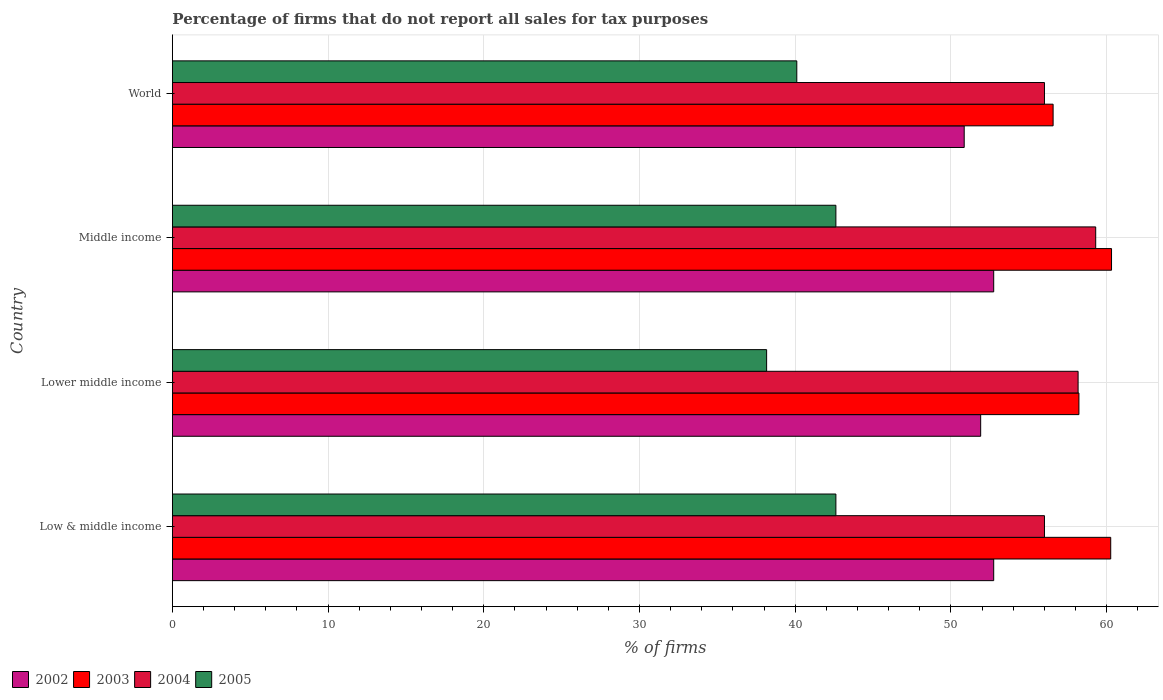How many different coloured bars are there?
Ensure brevity in your answer.  4. How many groups of bars are there?
Offer a terse response. 4. Are the number of bars per tick equal to the number of legend labels?
Your response must be concise. Yes. How many bars are there on the 4th tick from the bottom?
Provide a succinct answer. 4. In how many cases, is the number of bars for a given country not equal to the number of legend labels?
Give a very brief answer. 0. What is the percentage of firms that do not report all sales for tax purposes in 2002 in Lower middle income?
Give a very brief answer. 51.91. Across all countries, what is the maximum percentage of firms that do not report all sales for tax purposes in 2002?
Ensure brevity in your answer.  52.75. Across all countries, what is the minimum percentage of firms that do not report all sales for tax purposes in 2002?
Offer a very short reply. 50.85. In which country was the percentage of firms that do not report all sales for tax purposes in 2005 minimum?
Your response must be concise. Lower middle income. What is the total percentage of firms that do not report all sales for tax purposes in 2005 in the graph?
Offer a very short reply. 163.48. What is the difference between the percentage of firms that do not report all sales for tax purposes in 2005 in Lower middle income and that in Middle income?
Make the answer very short. -4.45. What is the difference between the percentage of firms that do not report all sales for tax purposes in 2003 in Lower middle income and the percentage of firms that do not report all sales for tax purposes in 2004 in Middle income?
Keep it short and to the point. -1.08. What is the average percentage of firms that do not report all sales for tax purposes in 2005 per country?
Make the answer very short. 40.87. What is the difference between the percentage of firms that do not report all sales for tax purposes in 2005 and percentage of firms that do not report all sales for tax purposes in 2003 in Low & middle income?
Your answer should be compact. -17.65. What is the ratio of the percentage of firms that do not report all sales for tax purposes in 2002 in Low & middle income to that in Lower middle income?
Offer a very short reply. 1.02. Is the percentage of firms that do not report all sales for tax purposes in 2002 in Middle income less than that in World?
Keep it short and to the point. No. What is the difference between the highest and the second highest percentage of firms that do not report all sales for tax purposes in 2004?
Offer a very short reply. 1.13. What is the difference between the highest and the lowest percentage of firms that do not report all sales for tax purposes in 2002?
Provide a short and direct response. 1.89. In how many countries, is the percentage of firms that do not report all sales for tax purposes in 2005 greater than the average percentage of firms that do not report all sales for tax purposes in 2005 taken over all countries?
Your response must be concise. 2. Is the sum of the percentage of firms that do not report all sales for tax purposes in 2005 in Low & middle income and Lower middle income greater than the maximum percentage of firms that do not report all sales for tax purposes in 2004 across all countries?
Offer a terse response. Yes. What does the 1st bar from the top in Middle income represents?
Provide a succinct answer. 2005. What does the 4th bar from the bottom in Middle income represents?
Offer a terse response. 2005. Is it the case that in every country, the sum of the percentage of firms that do not report all sales for tax purposes in 2002 and percentage of firms that do not report all sales for tax purposes in 2004 is greater than the percentage of firms that do not report all sales for tax purposes in 2003?
Keep it short and to the point. Yes. How many bars are there?
Your answer should be very brief. 16. Are all the bars in the graph horizontal?
Give a very brief answer. Yes. What is the difference between two consecutive major ticks on the X-axis?
Your answer should be compact. 10. Are the values on the major ticks of X-axis written in scientific E-notation?
Provide a short and direct response. No. How many legend labels are there?
Your answer should be compact. 4. What is the title of the graph?
Offer a terse response. Percentage of firms that do not report all sales for tax purposes. What is the label or title of the X-axis?
Offer a very short reply. % of firms. What is the label or title of the Y-axis?
Provide a short and direct response. Country. What is the % of firms of 2002 in Low & middle income?
Your answer should be very brief. 52.75. What is the % of firms of 2003 in Low & middle income?
Provide a short and direct response. 60.26. What is the % of firms in 2004 in Low & middle income?
Provide a succinct answer. 56.01. What is the % of firms of 2005 in Low & middle income?
Offer a very short reply. 42.61. What is the % of firms in 2002 in Lower middle income?
Keep it short and to the point. 51.91. What is the % of firms in 2003 in Lower middle income?
Keep it short and to the point. 58.22. What is the % of firms of 2004 in Lower middle income?
Ensure brevity in your answer.  58.16. What is the % of firms in 2005 in Lower middle income?
Ensure brevity in your answer.  38.16. What is the % of firms of 2002 in Middle income?
Give a very brief answer. 52.75. What is the % of firms in 2003 in Middle income?
Give a very brief answer. 60.31. What is the % of firms in 2004 in Middle income?
Offer a terse response. 59.3. What is the % of firms in 2005 in Middle income?
Keep it short and to the point. 42.61. What is the % of firms of 2002 in World?
Keep it short and to the point. 50.85. What is the % of firms of 2003 in World?
Give a very brief answer. 56.56. What is the % of firms in 2004 in World?
Your answer should be very brief. 56.01. What is the % of firms of 2005 in World?
Your answer should be compact. 40.1. Across all countries, what is the maximum % of firms in 2002?
Ensure brevity in your answer.  52.75. Across all countries, what is the maximum % of firms of 2003?
Your answer should be very brief. 60.31. Across all countries, what is the maximum % of firms in 2004?
Your response must be concise. 59.3. Across all countries, what is the maximum % of firms in 2005?
Provide a succinct answer. 42.61. Across all countries, what is the minimum % of firms of 2002?
Offer a terse response. 50.85. Across all countries, what is the minimum % of firms in 2003?
Provide a succinct answer. 56.56. Across all countries, what is the minimum % of firms of 2004?
Provide a succinct answer. 56.01. Across all countries, what is the minimum % of firms in 2005?
Give a very brief answer. 38.16. What is the total % of firms of 2002 in the graph?
Provide a succinct answer. 208.25. What is the total % of firms in 2003 in the graph?
Provide a short and direct response. 235.35. What is the total % of firms in 2004 in the graph?
Your answer should be very brief. 229.47. What is the total % of firms in 2005 in the graph?
Make the answer very short. 163.48. What is the difference between the % of firms in 2002 in Low & middle income and that in Lower middle income?
Your response must be concise. 0.84. What is the difference between the % of firms in 2003 in Low & middle income and that in Lower middle income?
Your response must be concise. 2.04. What is the difference between the % of firms in 2004 in Low & middle income and that in Lower middle income?
Your response must be concise. -2.16. What is the difference between the % of firms of 2005 in Low & middle income and that in Lower middle income?
Ensure brevity in your answer.  4.45. What is the difference between the % of firms in 2002 in Low & middle income and that in Middle income?
Offer a terse response. 0. What is the difference between the % of firms in 2003 in Low & middle income and that in Middle income?
Give a very brief answer. -0.05. What is the difference between the % of firms of 2004 in Low & middle income and that in Middle income?
Make the answer very short. -3.29. What is the difference between the % of firms of 2002 in Low & middle income and that in World?
Provide a succinct answer. 1.89. What is the difference between the % of firms of 2003 in Low & middle income and that in World?
Your answer should be compact. 3.7. What is the difference between the % of firms in 2004 in Low & middle income and that in World?
Your answer should be compact. 0. What is the difference between the % of firms in 2005 in Low & middle income and that in World?
Your answer should be very brief. 2.51. What is the difference between the % of firms of 2002 in Lower middle income and that in Middle income?
Your answer should be compact. -0.84. What is the difference between the % of firms in 2003 in Lower middle income and that in Middle income?
Your response must be concise. -2.09. What is the difference between the % of firms in 2004 in Lower middle income and that in Middle income?
Ensure brevity in your answer.  -1.13. What is the difference between the % of firms of 2005 in Lower middle income and that in Middle income?
Your response must be concise. -4.45. What is the difference between the % of firms in 2002 in Lower middle income and that in World?
Make the answer very short. 1.06. What is the difference between the % of firms of 2003 in Lower middle income and that in World?
Keep it short and to the point. 1.66. What is the difference between the % of firms of 2004 in Lower middle income and that in World?
Provide a short and direct response. 2.16. What is the difference between the % of firms in 2005 in Lower middle income and that in World?
Your answer should be very brief. -1.94. What is the difference between the % of firms in 2002 in Middle income and that in World?
Make the answer very short. 1.89. What is the difference between the % of firms of 2003 in Middle income and that in World?
Offer a very short reply. 3.75. What is the difference between the % of firms of 2004 in Middle income and that in World?
Ensure brevity in your answer.  3.29. What is the difference between the % of firms in 2005 in Middle income and that in World?
Your answer should be very brief. 2.51. What is the difference between the % of firms of 2002 in Low & middle income and the % of firms of 2003 in Lower middle income?
Offer a terse response. -5.47. What is the difference between the % of firms in 2002 in Low & middle income and the % of firms in 2004 in Lower middle income?
Make the answer very short. -5.42. What is the difference between the % of firms of 2002 in Low & middle income and the % of firms of 2005 in Lower middle income?
Offer a terse response. 14.58. What is the difference between the % of firms in 2003 in Low & middle income and the % of firms in 2004 in Lower middle income?
Your answer should be compact. 2.1. What is the difference between the % of firms in 2003 in Low & middle income and the % of firms in 2005 in Lower middle income?
Your answer should be very brief. 22.1. What is the difference between the % of firms of 2004 in Low & middle income and the % of firms of 2005 in Lower middle income?
Provide a succinct answer. 17.84. What is the difference between the % of firms of 2002 in Low & middle income and the % of firms of 2003 in Middle income?
Offer a terse response. -7.57. What is the difference between the % of firms of 2002 in Low & middle income and the % of firms of 2004 in Middle income?
Provide a succinct answer. -6.55. What is the difference between the % of firms in 2002 in Low & middle income and the % of firms in 2005 in Middle income?
Your answer should be very brief. 10.13. What is the difference between the % of firms in 2003 in Low & middle income and the % of firms in 2005 in Middle income?
Provide a short and direct response. 17.65. What is the difference between the % of firms of 2004 in Low & middle income and the % of firms of 2005 in Middle income?
Give a very brief answer. 13.39. What is the difference between the % of firms of 2002 in Low & middle income and the % of firms of 2003 in World?
Make the answer very short. -3.81. What is the difference between the % of firms in 2002 in Low & middle income and the % of firms in 2004 in World?
Your answer should be very brief. -3.26. What is the difference between the % of firms of 2002 in Low & middle income and the % of firms of 2005 in World?
Keep it short and to the point. 12.65. What is the difference between the % of firms in 2003 in Low & middle income and the % of firms in 2004 in World?
Your response must be concise. 4.25. What is the difference between the % of firms of 2003 in Low & middle income and the % of firms of 2005 in World?
Give a very brief answer. 20.16. What is the difference between the % of firms of 2004 in Low & middle income and the % of firms of 2005 in World?
Provide a short and direct response. 15.91. What is the difference between the % of firms of 2002 in Lower middle income and the % of firms of 2003 in Middle income?
Keep it short and to the point. -8.4. What is the difference between the % of firms in 2002 in Lower middle income and the % of firms in 2004 in Middle income?
Keep it short and to the point. -7.39. What is the difference between the % of firms in 2002 in Lower middle income and the % of firms in 2005 in Middle income?
Your answer should be very brief. 9.3. What is the difference between the % of firms of 2003 in Lower middle income and the % of firms of 2004 in Middle income?
Give a very brief answer. -1.08. What is the difference between the % of firms in 2003 in Lower middle income and the % of firms in 2005 in Middle income?
Make the answer very short. 15.61. What is the difference between the % of firms in 2004 in Lower middle income and the % of firms in 2005 in Middle income?
Provide a short and direct response. 15.55. What is the difference between the % of firms of 2002 in Lower middle income and the % of firms of 2003 in World?
Offer a terse response. -4.65. What is the difference between the % of firms in 2002 in Lower middle income and the % of firms in 2004 in World?
Ensure brevity in your answer.  -4.1. What is the difference between the % of firms in 2002 in Lower middle income and the % of firms in 2005 in World?
Offer a very short reply. 11.81. What is the difference between the % of firms of 2003 in Lower middle income and the % of firms of 2004 in World?
Your answer should be very brief. 2.21. What is the difference between the % of firms in 2003 in Lower middle income and the % of firms in 2005 in World?
Give a very brief answer. 18.12. What is the difference between the % of firms of 2004 in Lower middle income and the % of firms of 2005 in World?
Your answer should be compact. 18.07. What is the difference between the % of firms of 2002 in Middle income and the % of firms of 2003 in World?
Your answer should be very brief. -3.81. What is the difference between the % of firms of 2002 in Middle income and the % of firms of 2004 in World?
Your response must be concise. -3.26. What is the difference between the % of firms in 2002 in Middle income and the % of firms in 2005 in World?
Provide a short and direct response. 12.65. What is the difference between the % of firms in 2003 in Middle income and the % of firms in 2004 in World?
Provide a short and direct response. 4.31. What is the difference between the % of firms of 2003 in Middle income and the % of firms of 2005 in World?
Offer a very short reply. 20.21. What is the difference between the % of firms of 2004 in Middle income and the % of firms of 2005 in World?
Give a very brief answer. 19.2. What is the average % of firms of 2002 per country?
Keep it short and to the point. 52.06. What is the average % of firms of 2003 per country?
Give a very brief answer. 58.84. What is the average % of firms in 2004 per country?
Your answer should be very brief. 57.37. What is the average % of firms in 2005 per country?
Offer a terse response. 40.87. What is the difference between the % of firms of 2002 and % of firms of 2003 in Low & middle income?
Your answer should be compact. -7.51. What is the difference between the % of firms of 2002 and % of firms of 2004 in Low & middle income?
Keep it short and to the point. -3.26. What is the difference between the % of firms in 2002 and % of firms in 2005 in Low & middle income?
Offer a terse response. 10.13. What is the difference between the % of firms of 2003 and % of firms of 2004 in Low & middle income?
Give a very brief answer. 4.25. What is the difference between the % of firms in 2003 and % of firms in 2005 in Low & middle income?
Your answer should be very brief. 17.65. What is the difference between the % of firms of 2004 and % of firms of 2005 in Low & middle income?
Give a very brief answer. 13.39. What is the difference between the % of firms in 2002 and % of firms in 2003 in Lower middle income?
Offer a very short reply. -6.31. What is the difference between the % of firms of 2002 and % of firms of 2004 in Lower middle income?
Your answer should be compact. -6.26. What is the difference between the % of firms of 2002 and % of firms of 2005 in Lower middle income?
Provide a succinct answer. 13.75. What is the difference between the % of firms in 2003 and % of firms in 2004 in Lower middle income?
Make the answer very short. 0.05. What is the difference between the % of firms of 2003 and % of firms of 2005 in Lower middle income?
Give a very brief answer. 20.06. What is the difference between the % of firms of 2004 and % of firms of 2005 in Lower middle income?
Keep it short and to the point. 20. What is the difference between the % of firms of 2002 and % of firms of 2003 in Middle income?
Make the answer very short. -7.57. What is the difference between the % of firms of 2002 and % of firms of 2004 in Middle income?
Make the answer very short. -6.55. What is the difference between the % of firms in 2002 and % of firms in 2005 in Middle income?
Ensure brevity in your answer.  10.13. What is the difference between the % of firms in 2003 and % of firms in 2004 in Middle income?
Offer a terse response. 1.02. What is the difference between the % of firms of 2003 and % of firms of 2005 in Middle income?
Your answer should be very brief. 17.7. What is the difference between the % of firms of 2004 and % of firms of 2005 in Middle income?
Give a very brief answer. 16.69. What is the difference between the % of firms in 2002 and % of firms in 2003 in World?
Keep it short and to the point. -5.71. What is the difference between the % of firms in 2002 and % of firms in 2004 in World?
Your response must be concise. -5.15. What is the difference between the % of firms in 2002 and % of firms in 2005 in World?
Provide a short and direct response. 10.75. What is the difference between the % of firms of 2003 and % of firms of 2004 in World?
Keep it short and to the point. 0.56. What is the difference between the % of firms in 2003 and % of firms in 2005 in World?
Provide a succinct answer. 16.46. What is the difference between the % of firms in 2004 and % of firms in 2005 in World?
Your response must be concise. 15.91. What is the ratio of the % of firms of 2002 in Low & middle income to that in Lower middle income?
Your answer should be compact. 1.02. What is the ratio of the % of firms in 2003 in Low & middle income to that in Lower middle income?
Your answer should be compact. 1.04. What is the ratio of the % of firms in 2004 in Low & middle income to that in Lower middle income?
Keep it short and to the point. 0.96. What is the ratio of the % of firms of 2005 in Low & middle income to that in Lower middle income?
Your answer should be very brief. 1.12. What is the ratio of the % of firms of 2002 in Low & middle income to that in Middle income?
Make the answer very short. 1. What is the ratio of the % of firms of 2003 in Low & middle income to that in Middle income?
Your answer should be very brief. 1. What is the ratio of the % of firms in 2004 in Low & middle income to that in Middle income?
Ensure brevity in your answer.  0.94. What is the ratio of the % of firms in 2005 in Low & middle income to that in Middle income?
Provide a short and direct response. 1. What is the ratio of the % of firms of 2002 in Low & middle income to that in World?
Your answer should be compact. 1.04. What is the ratio of the % of firms of 2003 in Low & middle income to that in World?
Make the answer very short. 1.07. What is the ratio of the % of firms of 2005 in Low & middle income to that in World?
Keep it short and to the point. 1.06. What is the ratio of the % of firms of 2002 in Lower middle income to that in Middle income?
Offer a terse response. 0.98. What is the ratio of the % of firms in 2003 in Lower middle income to that in Middle income?
Your answer should be very brief. 0.97. What is the ratio of the % of firms of 2004 in Lower middle income to that in Middle income?
Provide a short and direct response. 0.98. What is the ratio of the % of firms in 2005 in Lower middle income to that in Middle income?
Offer a very short reply. 0.9. What is the ratio of the % of firms of 2002 in Lower middle income to that in World?
Offer a very short reply. 1.02. What is the ratio of the % of firms of 2003 in Lower middle income to that in World?
Give a very brief answer. 1.03. What is the ratio of the % of firms in 2004 in Lower middle income to that in World?
Offer a very short reply. 1.04. What is the ratio of the % of firms in 2005 in Lower middle income to that in World?
Offer a very short reply. 0.95. What is the ratio of the % of firms of 2002 in Middle income to that in World?
Provide a short and direct response. 1.04. What is the ratio of the % of firms in 2003 in Middle income to that in World?
Keep it short and to the point. 1.07. What is the ratio of the % of firms in 2004 in Middle income to that in World?
Your answer should be very brief. 1.06. What is the ratio of the % of firms in 2005 in Middle income to that in World?
Your answer should be very brief. 1.06. What is the difference between the highest and the second highest % of firms of 2003?
Provide a succinct answer. 0.05. What is the difference between the highest and the second highest % of firms of 2004?
Your response must be concise. 1.13. What is the difference between the highest and the lowest % of firms of 2002?
Keep it short and to the point. 1.89. What is the difference between the highest and the lowest % of firms in 2003?
Provide a succinct answer. 3.75. What is the difference between the highest and the lowest % of firms of 2004?
Ensure brevity in your answer.  3.29. What is the difference between the highest and the lowest % of firms in 2005?
Your response must be concise. 4.45. 